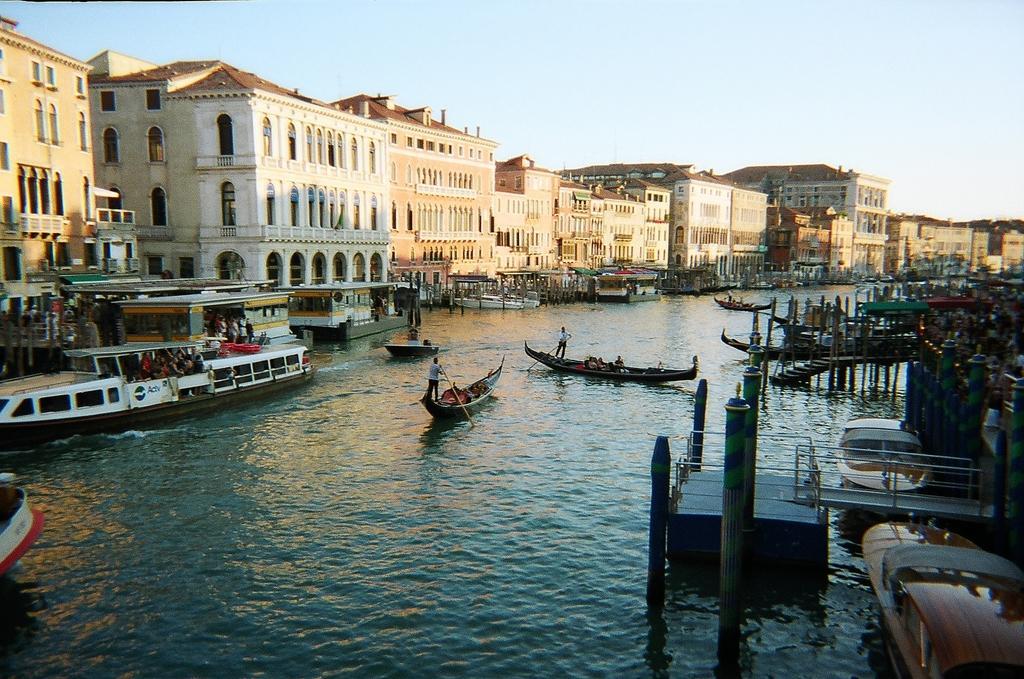Describe this image in one or two sentences. In this image I can see some boats on the water, beside them there are some buildings. 